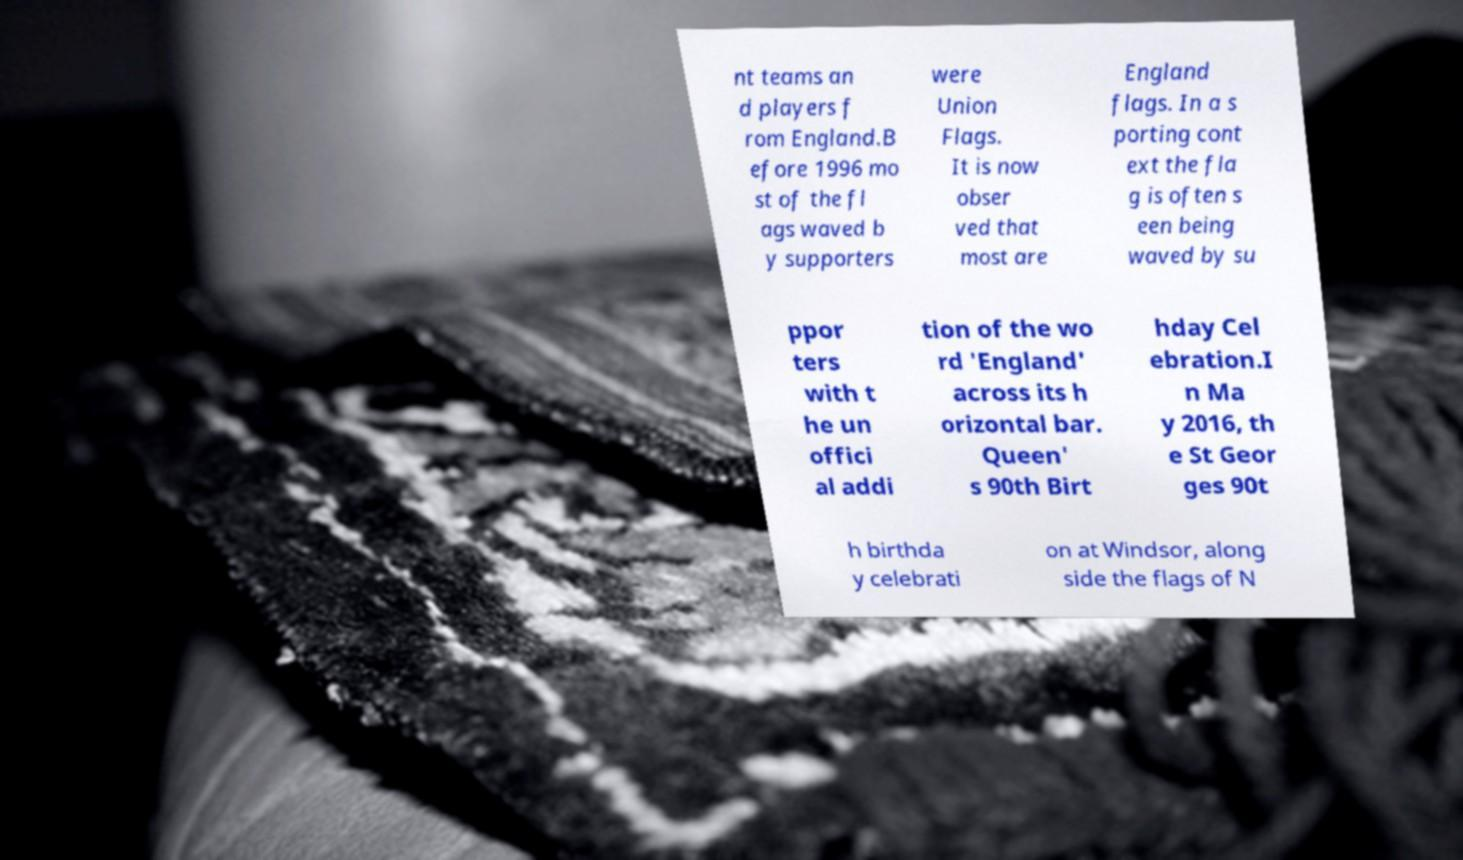There's text embedded in this image that I need extracted. Can you transcribe it verbatim? nt teams an d players f rom England.B efore 1996 mo st of the fl ags waved b y supporters were Union Flags. It is now obser ved that most are England flags. In a s porting cont ext the fla g is often s een being waved by su ppor ters with t he un offici al addi tion of the wo rd 'England' across its h orizontal bar. Queen' s 90th Birt hday Cel ebration.I n Ma y 2016, th e St Geor ges 90t h birthda y celebrati on at Windsor, along side the flags of N 